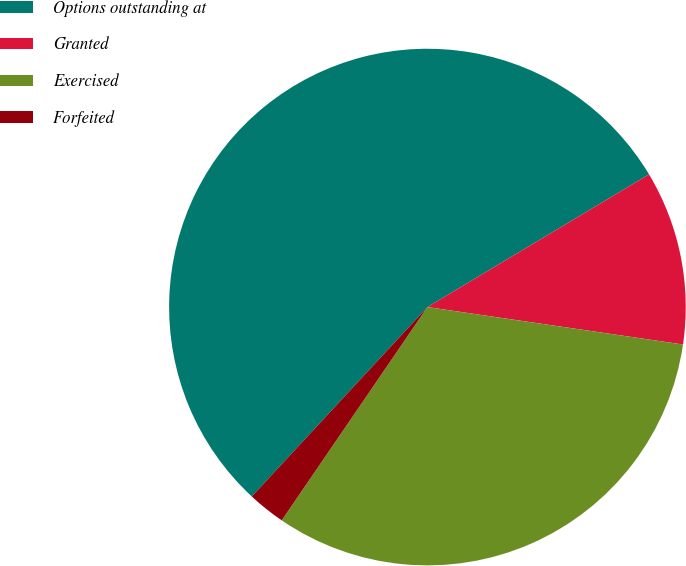Convert chart. <chart><loc_0><loc_0><loc_500><loc_500><pie_chart><fcel>Options outstanding at<fcel>Granted<fcel>Exercised<fcel>Forfeited<nl><fcel>54.51%<fcel>10.9%<fcel>32.22%<fcel>2.36%<nl></chart> 